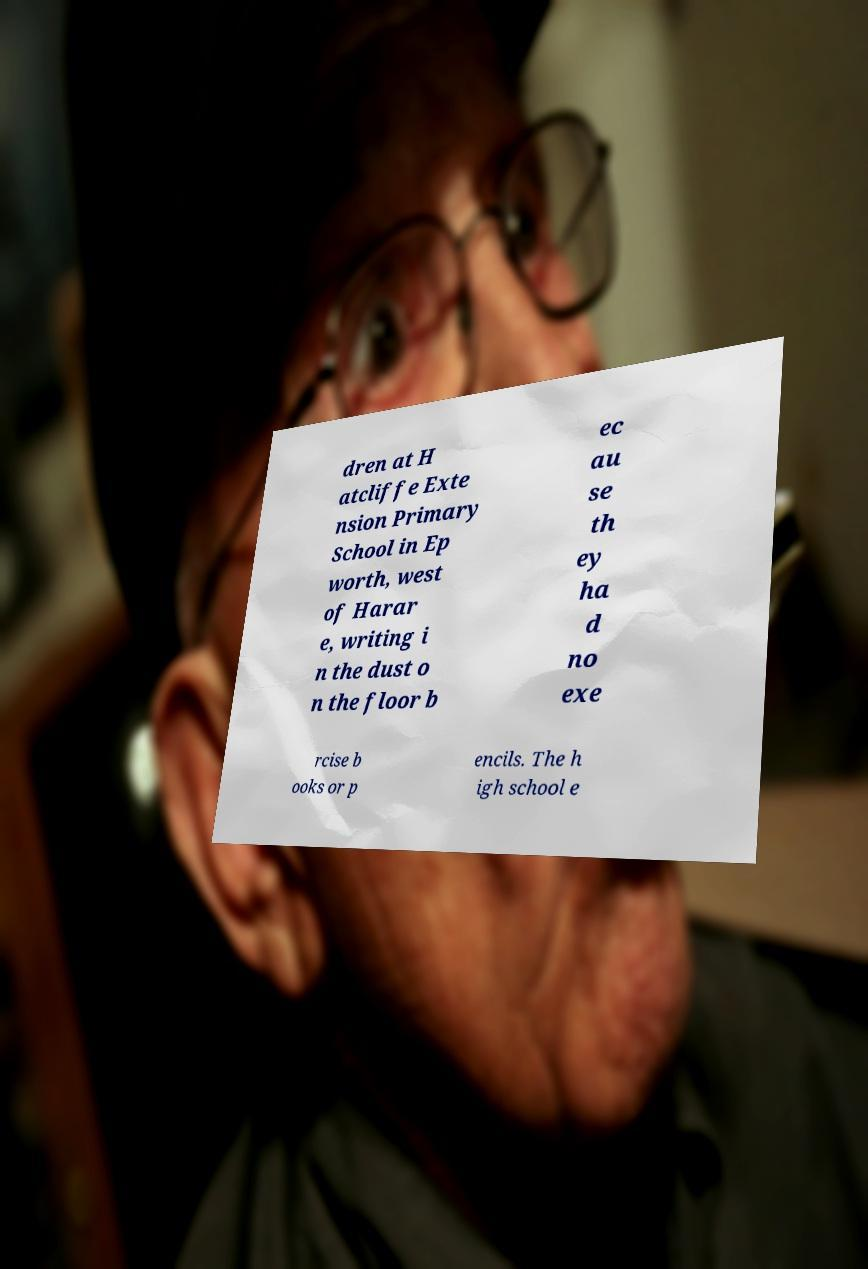There's text embedded in this image that I need extracted. Can you transcribe it verbatim? dren at H atcliffe Exte nsion Primary School in Ep worth, west of Harar e, writing i n the dust o n the floor b ec au se th ey ha d no exe rcise b ooks or p encils. The h igh school e 